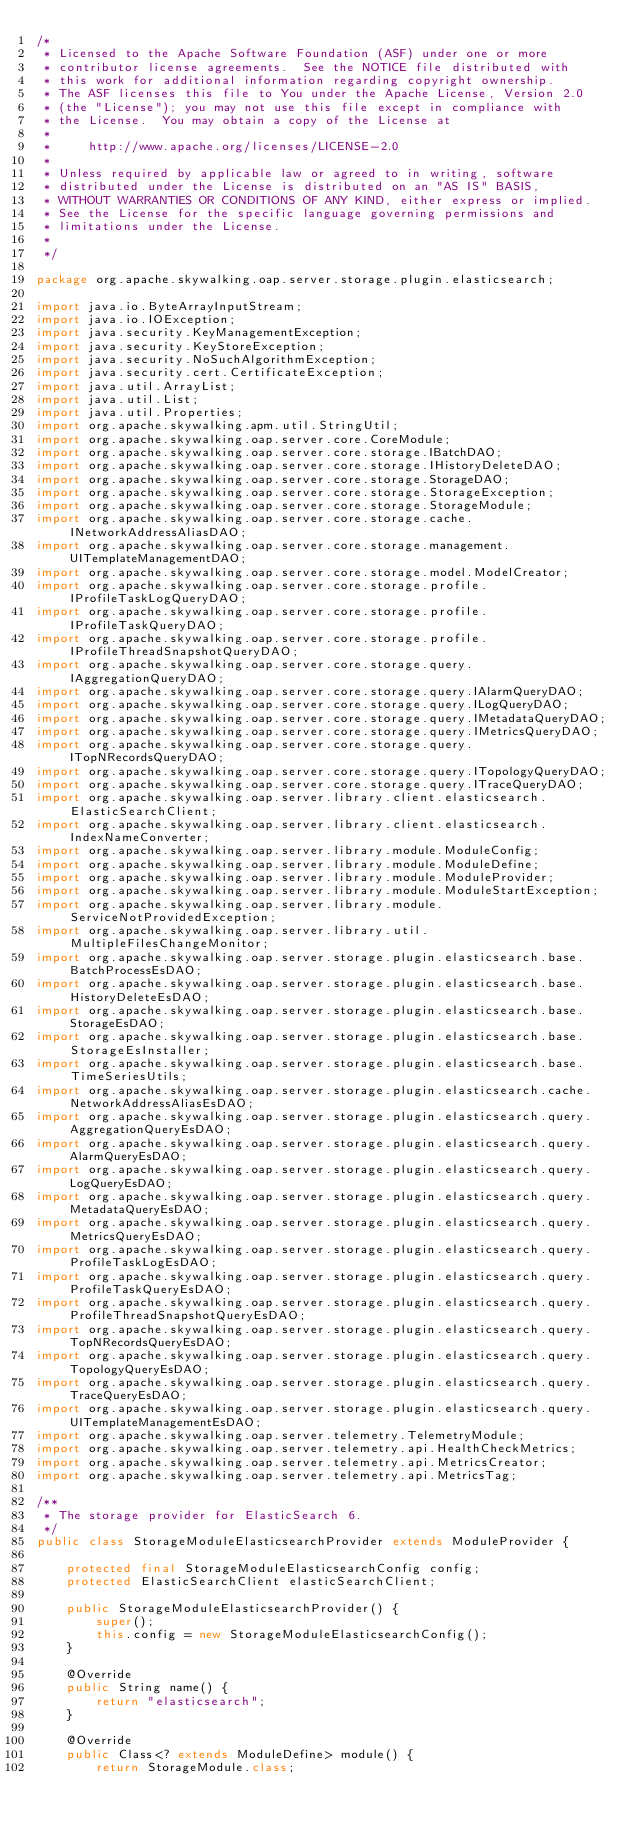<code> <loc_0><loc_0><loc_500><loc_500><_Java_>/*
 * Licensed to the Apache Software Foundation (ASF) under one or more
 * contributor license agreements.  See the NOTICE file distributed with
 * this work for additional information regarding copyright ownership.
 * The ASF licenses this file to You under the Apache License, Version 2.0
 * (the "License"); you may not use this file except in compliance with
 * the License.  You may obtain a copy of the License at
 *
 *     http://www.apache.org/licenses/LICENSE-2.0
 *
 * Unless required by applicable law or agreed to in writing, software
 * distributed under the License is distributed on an "AS IS" BASIS,
 * WITHOUT WARRANTIES OR CONDITIONS OF ANY KIND, either express or implied.
 * See the License for the specific language governing permissions and
 * limitations under the License.
 *
 */

package org.apache.skywalking.oap.server.storage.plugin.elasticsearch;

import java.io.ByteArrayInputStream;
import java.io.IOException;
import java.security.KeyManagementException;
import java.security.KeyStoreException;
import java.security.NoSuchAlgorithmException;
import java.security.cert.CertificateException;
import java.util.ArrayList;
import java.util.List;
import java.util.Properties;
import org.apache.skywalking.apm.util.StringUtil;
import org.apache.skywalking.oap.server.core.CoreModule;
import org.apache.skywalking.oap.server.core.storage.IBatchDAO;
import org.apache.skywalking.oap.server.core.storage.IHistoryDeleteDAO;
import org.apache.skywalking.oap.server.core.storage.StorageDAO;
import org.apache.skywalking.oap.server.core.storage.StorageException;
import org.apache.skywalking.oap.server.core.storage.StorageModule;
import org.apache.skywalking.oap.server.core.storage.cache.INetworkAddressAliasDAO;
import org.apache.skywalking.oap.server.core.storage.management.UITemplateManagementDAO;
import org.apache.skywalking.oap.server.core.storage.model.ModelCreator;
import org.apache.skywalking.oap.server.core.storage.profile.IProfileTaskLogQueryDAO;
import org.apache.skywalking.oap.server.core.storage.profile.IProfileTaskQueryDAO;
import org.apache.skywalking.oap.server.core.storage.profile.IProfileThreadSnapshotQueryDAO;
import org.apache.skywalking.oap.server.core.storage.query.IAggregationQueryDAO;
import org.apache.skywalking.oap.server.core.storage.query.IAlarmQueryDAO;
import org.apache.skywalking.oap.server.core.storage.query.ILogQueryDAO;
import org.apache.skywalking.oap.server.core.storage.query.IMetadataQueryDAO;
import org.apache.skywalking.oap.server.core.storage.query.IMetricsQueryDAO;
import org.apache.skywalking.oap.server.core.storage.query.ITopNRecordsQueryDAO;
import org.apache.skywalking.oap.server.core.storage.query.ITopologyQueryDAO;
import org.apache.skywalking.oap.server.core.storage.query.ITraceQueryDAO;
import org.apache.skywalking.oap.server.library.client.elasticsearch.ElasticSearchClient;
import org.apache.skywalking.oap.server.library.client.elasticsearch.IndexNameConverter;
import org.apache.skywalking.oap.server.library.module.ModuleConfig;
import org.apache.skywalking.oap.server.library.module.ModuleDefine;
import org.apache.skywalking.oap.server.library.module.ModuleProvider;
import org.apache.skywalking.oap.server.library.module.ModuleStartException;
import org.apache.skywalking.oap.server.library.module.ServiceNotProvidedException;
import org.apache.skywalking.oap.server.library.util.MultipleFilesChangeMonitor;
import org.apache.skywalking.oap.server.storage.plugin.elasticsearch.base.BatchProcessEsDAO;
import org.apache.skywalking.oap.server.storage.plugin.elasticsearch.base.HistoryDeleteEsDAO;
import org.apache.skywalking.oap.server.storage.plugin.elasticsearch.base.StorageEsDAO;
import org.apache.skywalking.oap.server.storage.plugin.elasticsearch.base.StorageEsInstaller;
import org.apache.skywalking.oap.server.storage.plugin.elasticsearch.base.TimeSeriesUtils;
import org.apache.skywalking.oap.server.storage.plugin.elasticsearch.cache.NetworkAddressAliasEsDAO;
import org.apache.skywalking.oap.server.storage.plugin.elasticsearch.query.AggregationQueryEsDAO;
import org.apache.skywalking.oap.server.storage.plugin.elasticsearch.query.AlarmQueryEsDAO;
import org.apache.skywalking.oap.server.storage.plugin.elasticsearch.query.LogQueryEsDAO;
import org.apache.skywalking.oap.server.storage.plugin.elasticsearch.query.MetadataQueryEsDAO;
import org.apache.skywalking.oap.server.storage.plugin.elasticsearch.query.MetricsQueryEsDAO;
import org.apache.skywalking.oap.server.storage.plugin.elasticsearch.query.ProfileTaskLogEsDAO;
import org.apache.skywalking.oap.server.storage.plugin.elasticsearch.query.ProfileTaskQueryEsDAO;
import org.apache.skywalking.oap.server.storage.plugin.elasticsearch.query.ProfileThreadSnapshotQueryEsDAO;
import org.apache.skywalking.oap.server.storage.plugin.elasticsearch.query.TopNRecordsQueryEsDAO;
import org.apache.skywalking.oap.server.storage.plugin.elasticsearch.query.TopologyQueryEsDAO;
import org.apache.skywalking.oap.server.storage.plugin.elasticsearch.query.TraceQueryEsDAO;
import org.apache.skywalking.oap.server.storage.plugin.elasticsearch.query.UITemplateManagementEsDAO;
import org.apache.skywalking.oap.server.telemetry.TelemetryModule;
import org.apache.skywalking.oap.server.telemetry.api.HealthCheckMetrics;
import org.apache.skywalking.oap.server.telemetry.api.MetricsCreator;
import org.apache.skywalking.oap.server.telemetry.api.MetricsTag;

/**
 * The storage provider for ElasticSearch 6.
 */
public class StorageModuleElasticsearchProvider extends ModuleProvider {

    protected final StorageModuleElasticsearchConfig config;
    protected ElasticSearchClient elasticSearchClient;

    public StorageModuleElasticsearchProvider() {
        super();
        this.config = new StorageModuleElasticsearchConfig();
    }

    @Override
    public String name() {
        return "elasticsearch";
    }

    @Override
    public Class<? extends ModuleDefine> module() {
        return StorageModule.class;</code> 